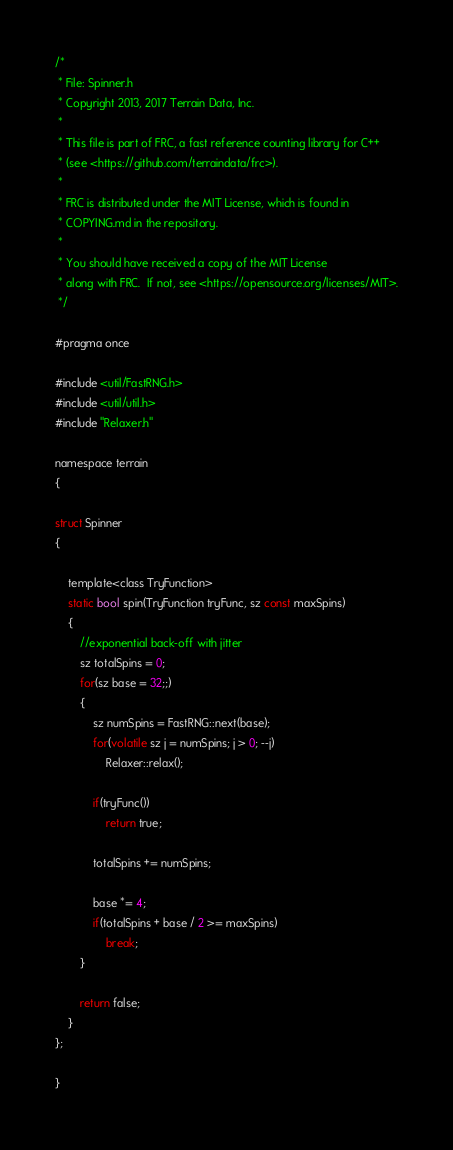<code> <loc_0><loc_0><loc_500><loc_500><_C_>/*
 * File: Spinner.h
 * Copyright 2013, 2017 Terrain Data, Inc.
 *
 * This file is part of FRC, a fast reference counting library for C++
 * (see <https://github.com/terraindata/frc>).
 *
 * FRC is distributed under the MIT License, which is found in
 * COPYING.md in the repository.
 *
 * You should have received a copy of the MIT License
 * along with FRC.  If not, see <https://opensource.org/licenses/MIT>.
 */

#pragma once

#include <util/FastRNG.h>
#include <util/util.h>
#include "Relaxer.h"

namespace terrain
{

struct Spinner
{

    template<class TryFunction>
    static bool spin(TryFunction tryFunc, sz const maxSpins)
    {
        //exponential back-off with jitter
        sz totalSpins = 0;
        for(sz base = 32;;)
        {
            sz numSpins = FastRNG::next(base);
            for(volatile sz j = numSpins; j > 0; --j)
                Relaxer::relax();

            if(tryFunc())
                return true;

            totalSpins += numSpins;

            base *= 4;
            if(totalSpins + base / 2 >= maxSpins)
                break;
        }

        return false;
    }
};

}
</code> 